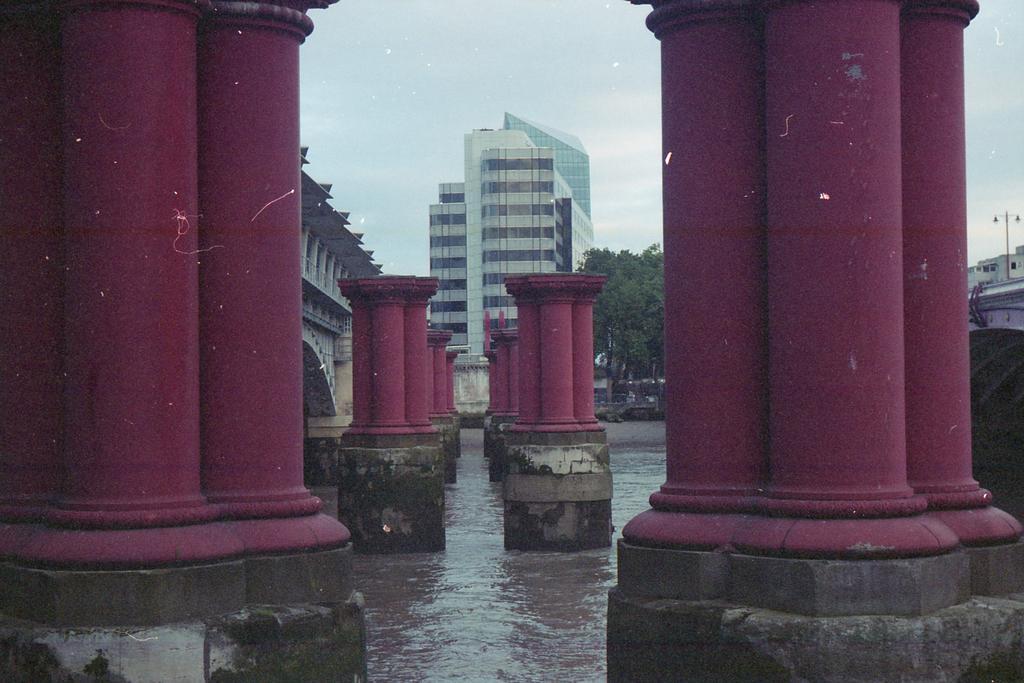Please provide a concise description of this image. In the picture we can see four joint pillars on the stone which are purple in color and they are arranged in the sequence and behind it, we can see a building and a tower building with many floors and beside it we can see some trees and behind it we can see a sky with clouds. 